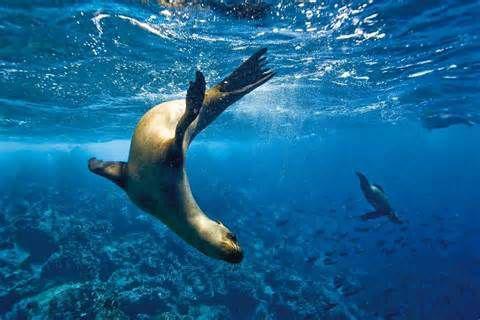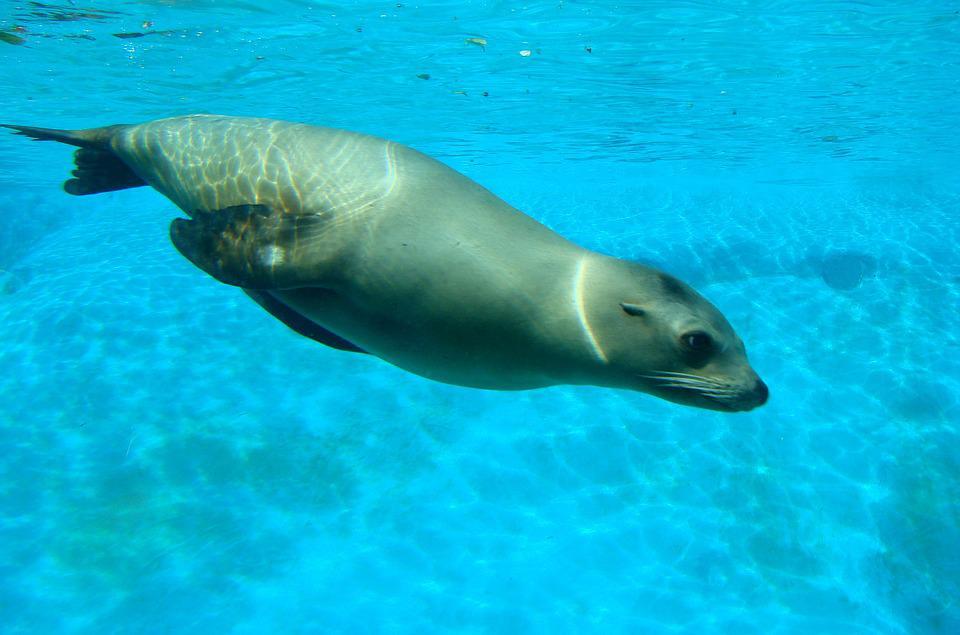The first image is the image on the left, the second image is the image on the right. Given the left and right images, does the statement "There are two seals swimming in the ocean." hold true? Answer yes or no. No. The first image is the image on the left, the second image is the image on the right. For the images shown, is this caption "One of the seals are swimming UP towards the surface." true? Answer yes or no. No. 